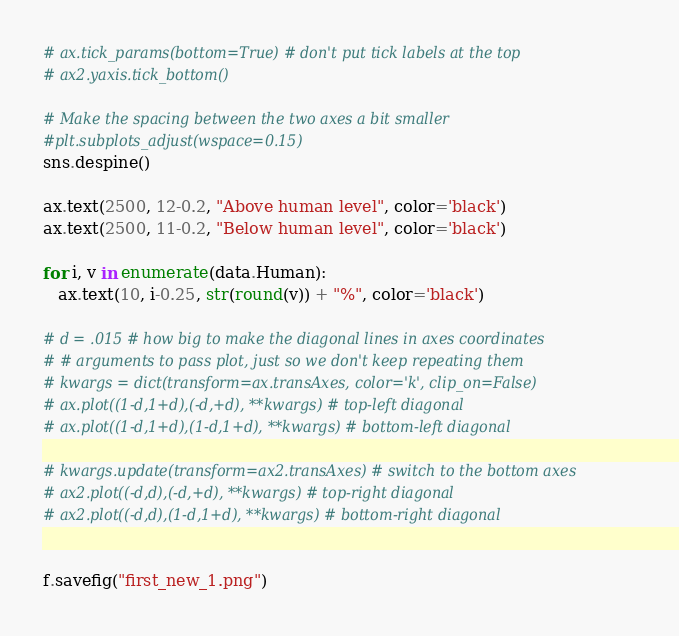Convert code to text. <code><loc_0><loc_0><loc_500><loc_500><_Python_># ax.tick_params(bottom=True) # don't put tick labels at the top
# ax2.yaxis.tick_bottom()

# Make the spacing between the two axes a bit smaller
#plt.subplots_adjust(wspace=0.15)
sns.despine()

ax.text(2500, 12-0.2, "Above human level", color='black')
ax.text(2500, 11-0.2, "Below human level", color='black')

for i, v in enumerate(data.Human):
   ax.text(10, i-0.25, str(round(v)) + "%", color='black')

# d = .015 # how big to make the diagonal lines in axes coordinates
# # arguments to pass plot, just so we don't keep repeating them
# kwargs = dict(transform=ax.transAxes, color='k', clip_on=False)
# ax.plot((1-d,1+d),(-d,+d), **kwargs) # top-left diagonal
# ax.plot((1-d,1+d),(1-d,1+d), **kwargs) # bottom-left diagonal

# kwargs.update(transform=ax2.transAxes) # switch to the bottom axes
# ax2.plot((-d,d),(-d,+d), **kwargs) # top-right diagonal
# ax2.plot((-d,d),(1-d,1+d), **kwargs) # bottom-right diagonal


f.savefig("first_new_1.png")</code> 